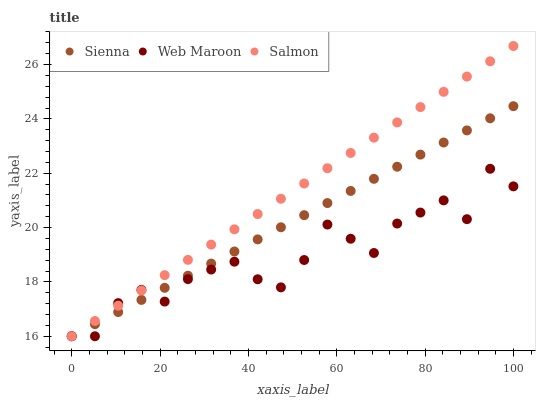Does Web Maroon have the minimum area under the curve?
Answer yes or no. Yes. Does Salmon have the maximum area under the curve?
Answer yes or no. Yes. Does Salmon have the minimum area under the curve?
Answer yes or no. No. Does Web Maroon have the maximum area under the curve?
Answer yes or no. No. Is Sienna the smoothest?
Answer yes or no. Yes. Is Web Maroon the roughest?
Answer yes or no. Yes. Is Salmon the smoothest?
Answer yes or no. No. Is Salmon the roughest?
Answer yes or no. No. Does Sienna have the lowest value?
Answer yes or no. Yes. Does Salmon have the highest value?
Answer yes or no. Yes. Does Web Maroon have the highest value?
Answer yes or no. No. Does Salmon intersect Sienna?
Answer yes or no. Yes. Is Salmon less than Sienna?
Answer yes or no. No. Is Salmon greater than Sienna?
Answer yes or no. No. 